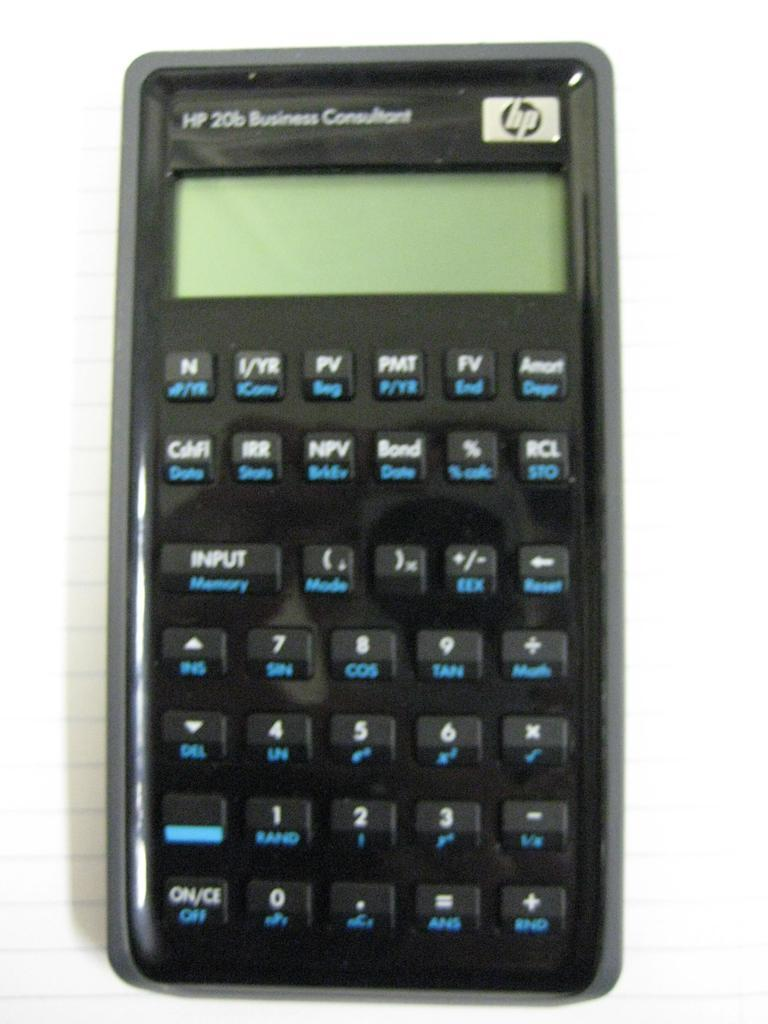<image>
Provide a brief description of the given image. Black and gray HP 20b Business Consultant hp calculator 